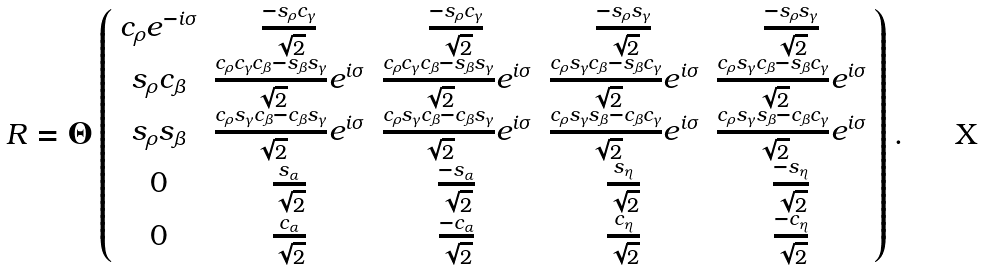<formula> <loc_0><loc_0><loc_500><loc_500>R = \Theta \left ( \begin{array} { c c c c c } c _ { \rho } e ^ { - i \sigma } & \frac { - s _ { \rho } c _ { \gamma } } { \sqrt { 2 } } & \frac { - s _ { \rho } c _ { \gamma } } { \sqrt { 2 } } & \frac { - s _ { \rho } s _ { \gamma } } { \sqrt { 2 } } & \frac { - s _ { \rho } s _ { \gamma } } { \sqrt { 2 } } \\ s _ { \rho } c _ { \beta } & \frac { c _ { \rho } c _ { \gamma } c _ { \beta } - s _ { \beta } s _ { \gamma } } { \sqrt { 2 } } e ^ { i \sigma } & \frac { c _ { \rho } c _ { \gamma } c _ { \beta } - s _ { \beta } s _ { \gamma } } { \sqrt { 2 } } e ^ { i \sigma } & \frac { c _ { \rho } s _ { \gamma } c _ { \beta } - s _ { \beta } c _ { \gamma } } { \sqrt { 2 } } e ^ { i \sigma } & \frac { c _ { \rho } s _ { \gamma } c _ { \beta } - s _ { \beta } c _ { \gamma } } { \sqrt { 2 } } e ^ { i \sigma } \\ s _ { \rho } s _ { \beta } & \frac { c _ { \rho } s _ { \gamma } c _ { \beta } - c _ { \beta } s _ { \gamma } } { \sqrt { 2 } } e ^ { i \sigma } & \frac { c _ { \rho } s _ { \gamma } c _ { \beta } - c _ { \beta } s _ { \gamma } } { \sqrt { 2 } } e ^ { i \sigma } & \frac { c _ { \rho } s _ { \gamma } s _ { \beta } - c _ { \beta } c _ { \gamma } } { \sqrt { 2 } } e ^ { i \sigma } & \frac { c _ { \rho } s _ { \gamma } s _ { \beta } - c _ { \beta } c _ { \gamma } } { \sqrt { 2 } } e ^ { i \sigma } \\ 0 & \frac { s _ { \alpha } } { \sqrt { 2 } } & \frac { - s _ { \alpha } } { \sqrt { 2 } } & \frac { s _ { \eta } } { \sqrt { 2 } } & \frac { - s _ { \eta } } { \sqrt { 2 } } \\ 0 & \frac { c _ { \alpha } } { \sqrt { 2 } } & \frac { - c _ { \alpha } } { \sqrt { 2 } } & \frac { c _ { \eta } } { \sqrt { 2 } } & \frac { - c _ { \eta } } { \sqrt { 2 } } \end{array} \right ) .</formula> 